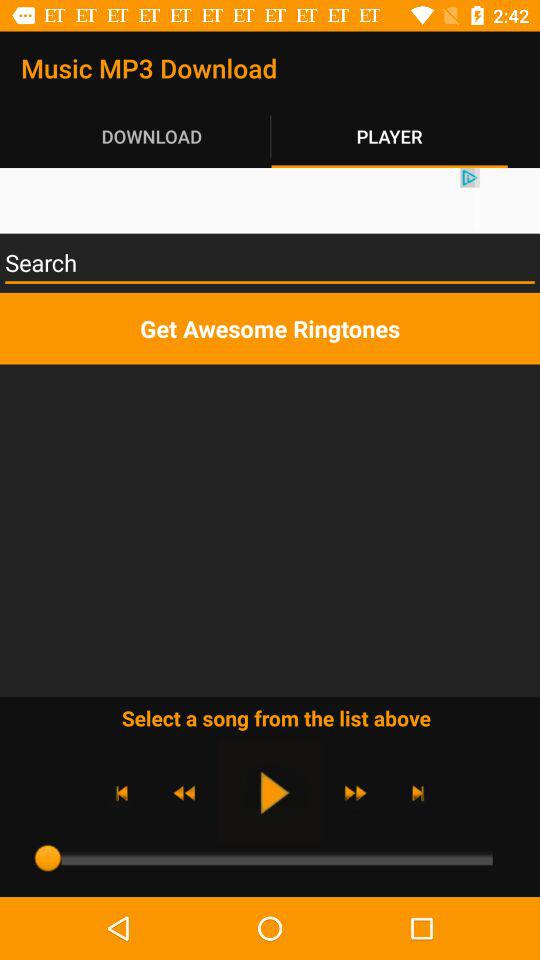What are the listed ringtones?
When the provided information is insufficient, respond with <no answer>. <no answer> 